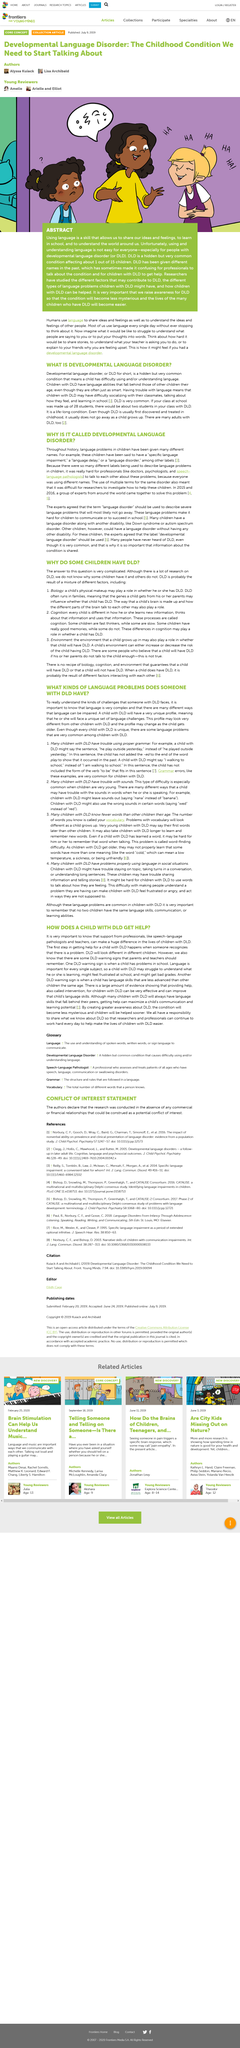Indicate a few pertinent items in this graphic. The use of the term "language disorder" to describe severe and persistent language problems was agreed upon by experts. Developmental Language Disorder is a condition that is characterized by difficulty in the acquisition and use of language, which is commonly referred to as DLD. The presence of the environment is a factor in the determination of whether the defendant has a limited license to drive (DLD). In the example provided in paragraph 2, the fruit used to illustrate how children might leave sounds out is banana. In the third paragraph of the article, a number is displayed in brackets at the end of the paragraph. 